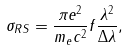<formula> <loc_0><loc_0><loc_500><loc_500>\sigma _ { R S } = \frac { \pi e ^ { 2 } } { m _ { e } c ^ { 2 } } f \frac { \lambda ^ { 2 } } { \Delta \lambda } ,</formula> 